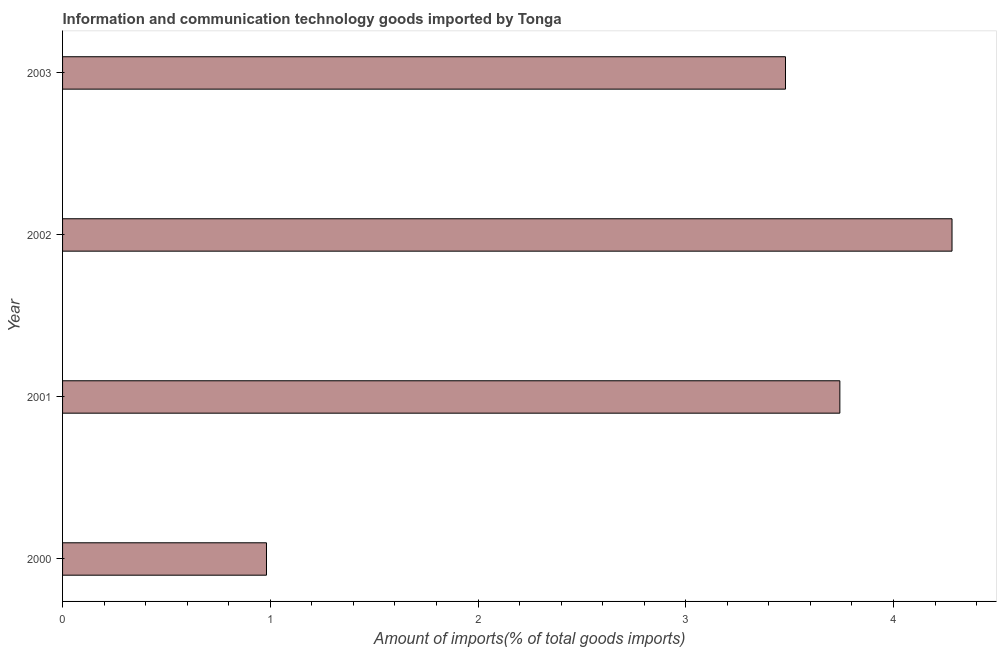Does the graph contain any zero values?
Make the answer very short. No. What is the title of the graph?
Offer a terse response. Information and communication technology goods imported by Tonga. What is the label or title of the X-axis?
Offer a terse response. Amount of imports(% of total goods imports). What is the amount of ict goods imports in 2000?
Keep it short and to the point. 0.98. Across all years, what is the maximum amount of ict goods imports?
Provide a short and direct response. 4.28. Across all years, what is the minimum amount of ict goods imports?
Keep it short and to the point. 0.98. In which year was the amount of ict goods imports maximum?
Your answer should be compact. 2002. What is the sum of the amount of ict goods imports?
Offer a very short reply. 12.49. What is the difference between the amount of ict goods imports in 2000 and 2003?
Your answer should be compact. -2.5. What is the average amount of ict goods imports per year?
Provide a short and direct response. 3.12. What is the median amount of ict goods imports?
Offer a very short reply. 3.61. Do a majority of the years between 2000 and 2001 (inclusive) have amount of ict goods imports greater than 0.2 %?
Your answer should be compact. Yes. What is the ratio of the amount of ict goods imports in 2002 to that in 2003?
Make the answer very short. 1.23. Is the amount of ict goods imports in 2000 less than that in 2001?
Make the answer very short. Yes. What is the difference between the highest and the second highest amount of ict goods imports?
Make the answer very short. 0.54. Is the sum of the amount of ict goods imports in 2001 and 2003 greater than the maximum amount of ict goods imports across all years?
Provide a succinct answer. Yes. What is the difference between the highest and the lowest amount of ict goods imports?
Your response must be concise. 3.3. Are all the bars in the graph horizontal?
Provide a short and direct response. Yes. How many years are there in the graph?
Your response must be concise. 4. What is the difference between two consecutive major ticks on the X-axis?
Make the answer very short. 1. What is the Amount of imports(% of total goods imports) of 2000?
Offer a very short reply. 0.98. What is the Amount of imports(% of total goods imports) of 2001?
Offer a very short reply. 3.74. What is the Amount of imports(% of total goods imports) of 2002?
Offer a terse response. 4.28. What is the Amount of imports(% of total goods imports) in 2003?
Offer a terse response. 3.48. What is the difference between the Amount of imports(% of total goods imports) in 2000 and 2001?
Keep it short and to the point. -2.76. What is the difference between the Amount of imports(% of total goods imports) in 2000 and 2002?
Keep it short and to the point. -3.3. What is the difference between the Amount of imports(% of total goods imports) in 2000 and 2003?
Make the answer very short. -2.5. What is the difference between the Amount of imports(% of total goods imports) in 2001 and 2002?
Make the answer very short. -0.54. What is the difference between the Amount of imports(% of total goods imports) in 2001 and 2003?
Ensure brevity in your answer.  0.26. What is the difference between the Amount of imports(% of total goods imports) in 2002 and 2003?
Your answer should be compact. 0.8. What is the ratio of the Amount of imports(% of total goods imports) in 2000 to that in 2001?
Make the answer very short. 0.26. What is the ratio of the Amount of imports(% of total goods imports) in 2000 to that in 2002?
Keep it short and to the point. 0.23. What is the ratio of the Amount of imports(% of total goods imports) in 2000 to that in 2003?
Offer a very short reply. 0.28. What is the ratio of the Amount of imports(% of total goods imports) in 2001 to that in 2002?
Offer a terse response. 0.87. What is the ratio of the Amount of imports(% of total goods imports) in 2001 to that in 2003?
Provide a short and direct response. 1.07. What is the ratio of the Amount of imports(% of total goods imports) in 2002 to that in 2003?
Your answer should be very brief. 1.23. 